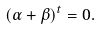Convert formula to latex. <formula><loc_0><loc_0><loc_500><loc_500>( \alpha + \beta ) ^ { t } = 0 .</formula> 